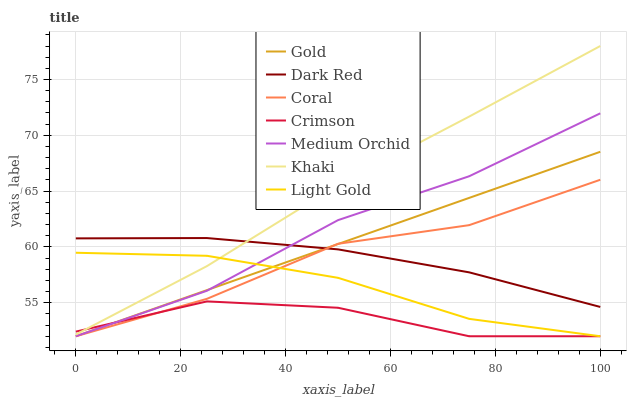Does Crimson have the minimum area under the curve?
Answer yes or no. Yes. Does Khaki have the maximum area under the curve?
Answer yes or no. Yes. Does Gold have the minimum area under the curve?
Answer yes or no. No. Does Gold have the maximum area under the curve?
Answer yes or no. No. Is Gold the smoothest?
Answer yes or no. Yes. Is Crimson the roughest?
Answer yes or no. Yes. Is Dark Red the smoothest?
Answer yes or no. No. Is Dark Red the roughest?
Answer yes or no. No. Does Dark Red have the lowest value?
Answer yes or no. No. Does Khaki have the highest value?
Answer yes or no. Yes. Does Gold have the highest value?
Answer yes or no. No. Is Gold less than Khaki?
Answer yes or no. Yes. Is Dark Red greater than Light Gold?
Answer yes or no. Yes. Does Gold intersect Khaki?
Answer yes or no. No. 